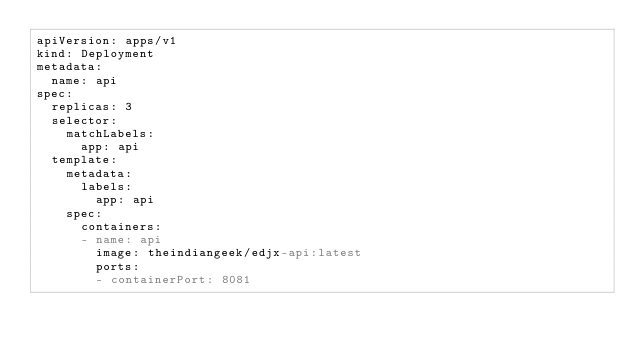<code> <loc_0><loc_0><loc_500><loc_500><_YAML_>apiVersion: apps/v1
kind: Deployment
metadata:
  name: api
spec:
  replicas: 3
  selector:
    matchLabels:
      app: api
  template:
    metadata:
      labels:
        app: api
    spec:
      containers:
      - name: api
        image: theindiangeek/edjx-api:latest
        ports:
        - containerPort: 8081
</code> 